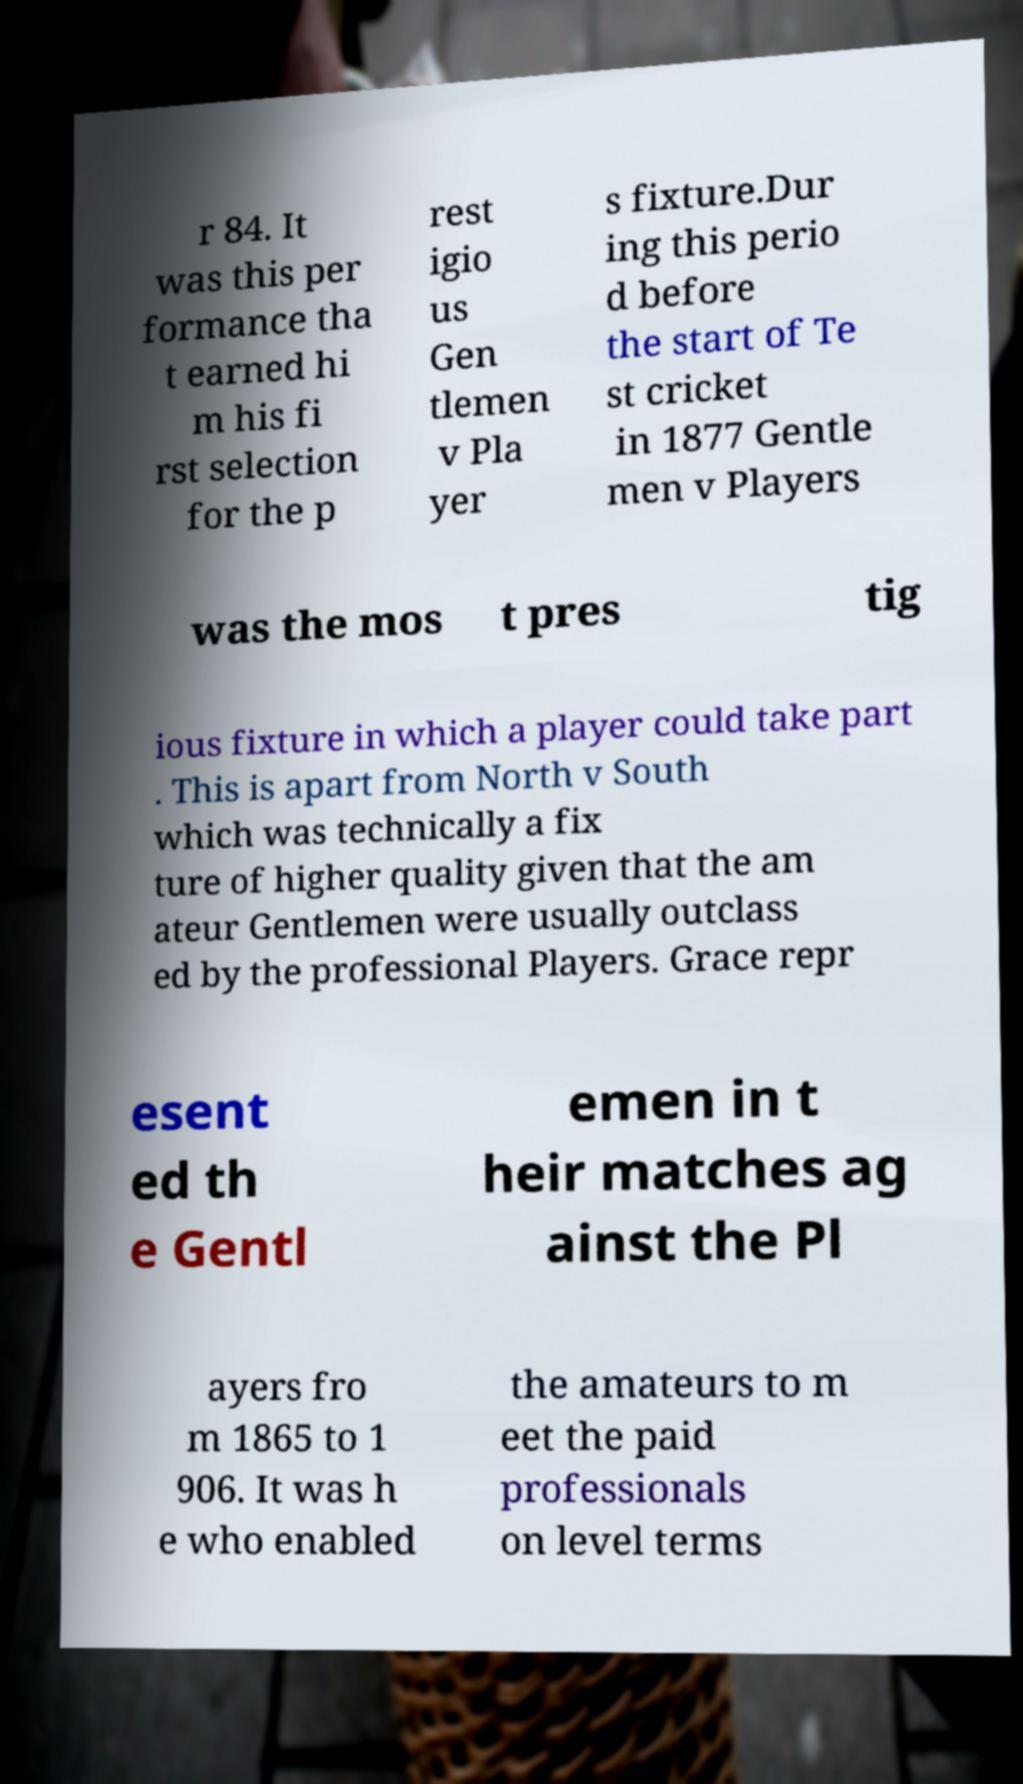Can you read and provide the text displayed in the image?This photo seems to have some interesting text. Can you extract and type it out for me? r 84. It was this per formance tha t earned hi m his fi rst selection for the p rest igio us Gen tlemen v Pla yer s fixture.Dur ing this perio d before the start of Te st cricket in 1877 Gentle men v Players was the mos t pres tig ious fixture in which a player could take part . This is apart from North v South which was technically a fix ture of higher quality given that the am ateur Gentlemen were usually outclass ed by the professional Players. Grace repr esent ed th e Gentl emen in t heir matches ag ainst the Pl ayers fro m 1865 to 1 906. It was h e who enabled the amateurs to m eet the paid professionals on level terms 